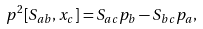<formula> <loc_0><loc_0><loc_500><loc_500>p ^ { 2 } [ S _ { a b } , x _ { c } ] = S _ { a c } p _ { b } - S _ { b c } p _ { a } ,</formula> 